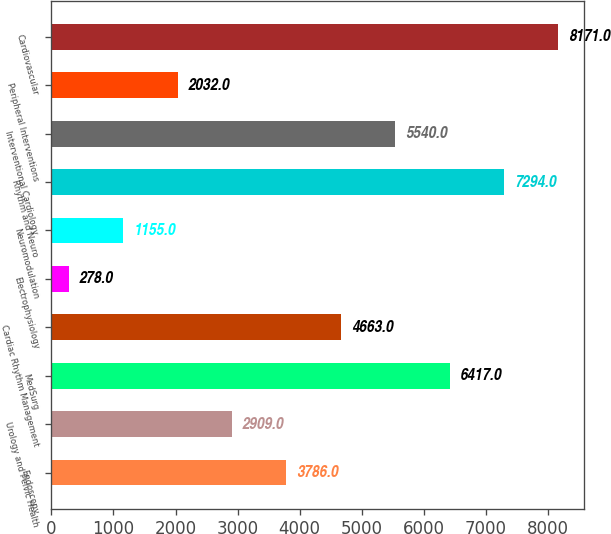<chart> <loc_0><loc_0><loc_500><loc_500><bar_chart><fcel>Endoscopy<fcel>Urology and Pelvic Health<fcel>MedSurg<fcel>Cardiac Rhythm Management<fcel>Electrophysiology<fcel>Neuromodulation<fcel>Rhythm and Neuro<fcel>Interventional Cardiology<fcel>Peripheral Interventions<fcel>Cardiovascular<nl><fcel>3786<fcel>2909<fcel>6417<fcel>4663<fcel>278<fcel>1155<fcel>7294<fcel>5540<fcel>2032<fcel>8171<nl></chart> 